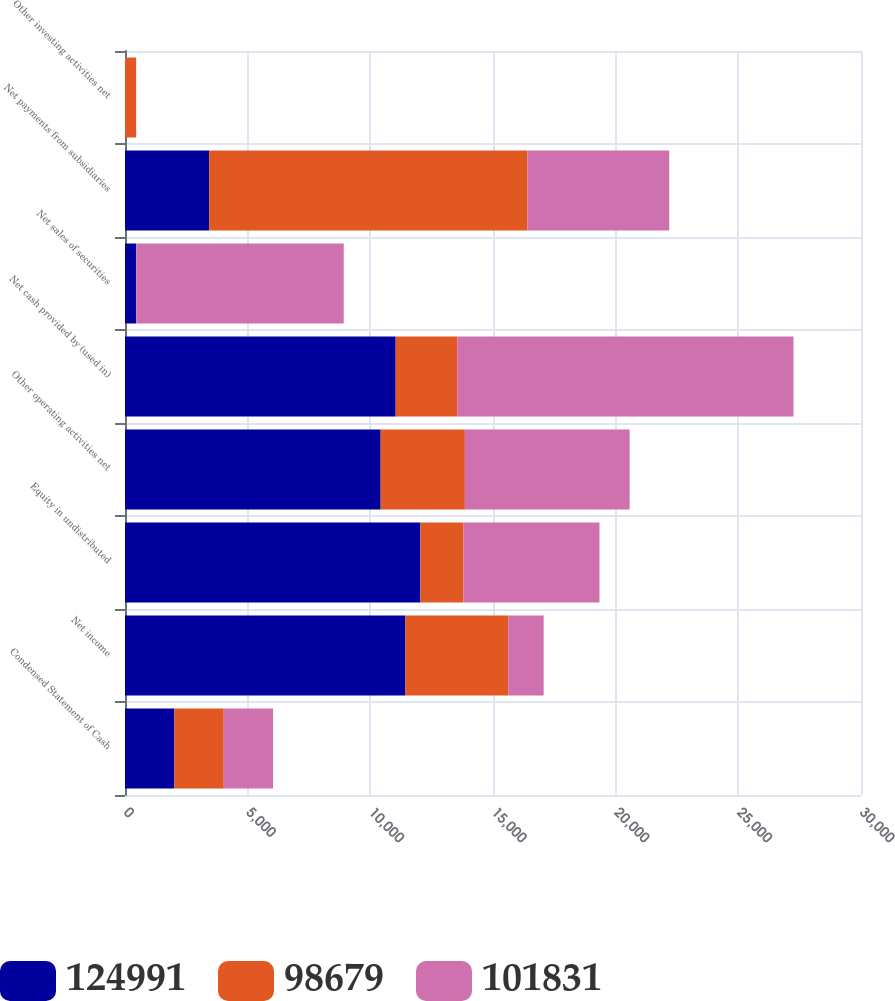<chart> <loc_0><loc_0><loc_500><loc_500><stacked_bar_chart><ecel><fcel>Condensed Statement of Cash<fcel>Net income<fcel>Equity in undistributed<fcel>Other operating activities net<fcel>Net cash provided by (used in)<fcel>Net sales of securities<fcel>Net payments from subsidiaries<fcel>Other investing activities net<nl><fcel>124991<fcel>2013<fcel>11431<fcel>12042<fcel>10422<fcel>11033<fcel>459<fcel>3432<fcel>3<nl><fcel>98679<fcel>2012<fcel>4188<fcel>1754<fcel>3432<fcel>2510<fcel>13<fcel>12973<fcel>445<nl><fcel>101831<fcel>2011<fcel>1446<fcel>5544<fcel>6716<fcel>13706<fcel>8444<fcel>5780<fcel>8<nl></chart> 